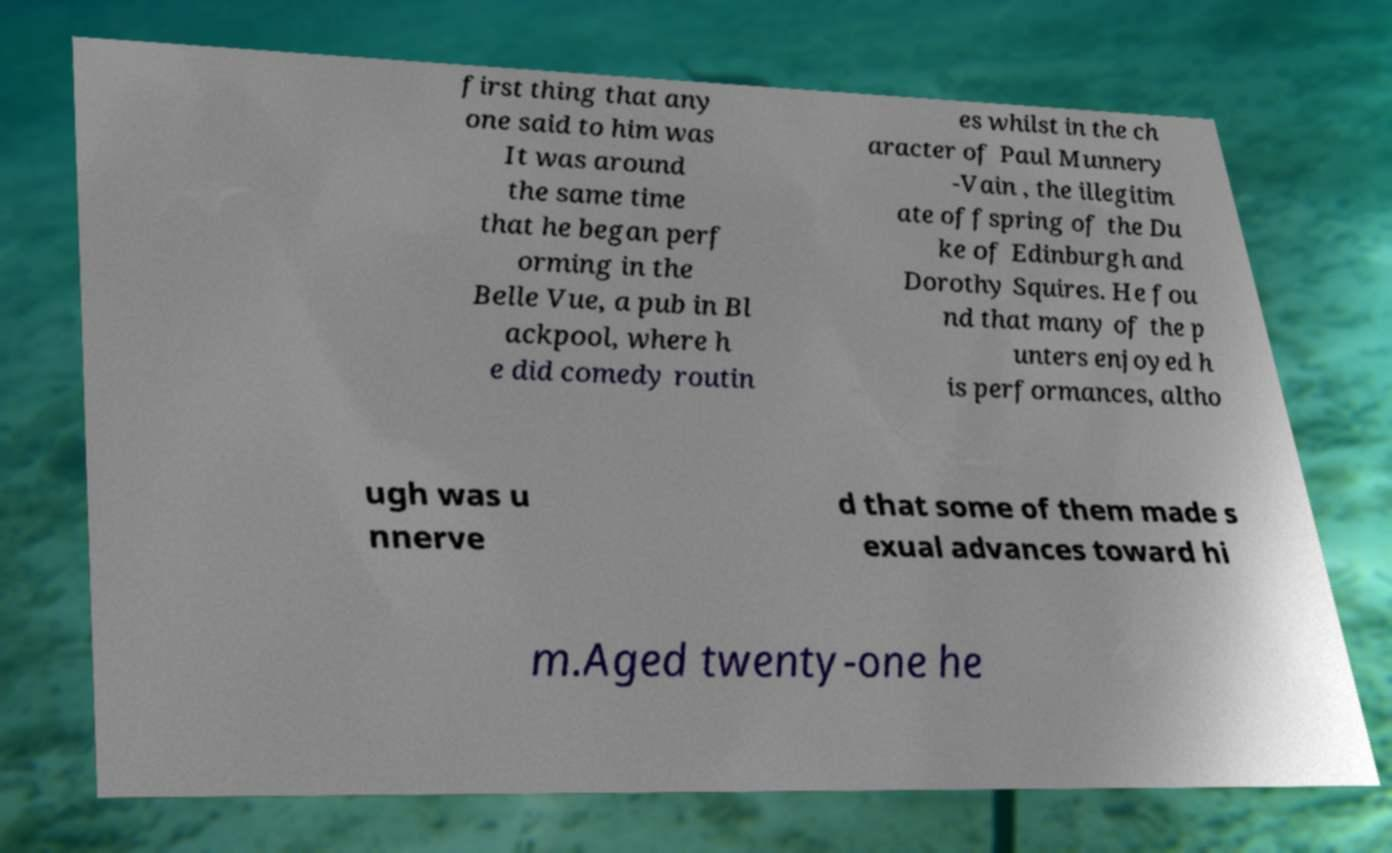Could you assist in decoding the text presented in this image and type it out clearly? first thing that any one said to him was It was around the same time that he began perf orming in the Belle Vue, a pub in Bl ackpool, where h e did comedy routin es whilst in the ch aracter of Paul Munnery -Vain , the illegitim ate offspring of the Du ke of Edinburgh and Dorothy Squires. He fou nd that many of the p unters enjoyed h is performances, altho ugh was u nnerve d that some of them made s exual advances toward hi m.Aged twenty-one he 